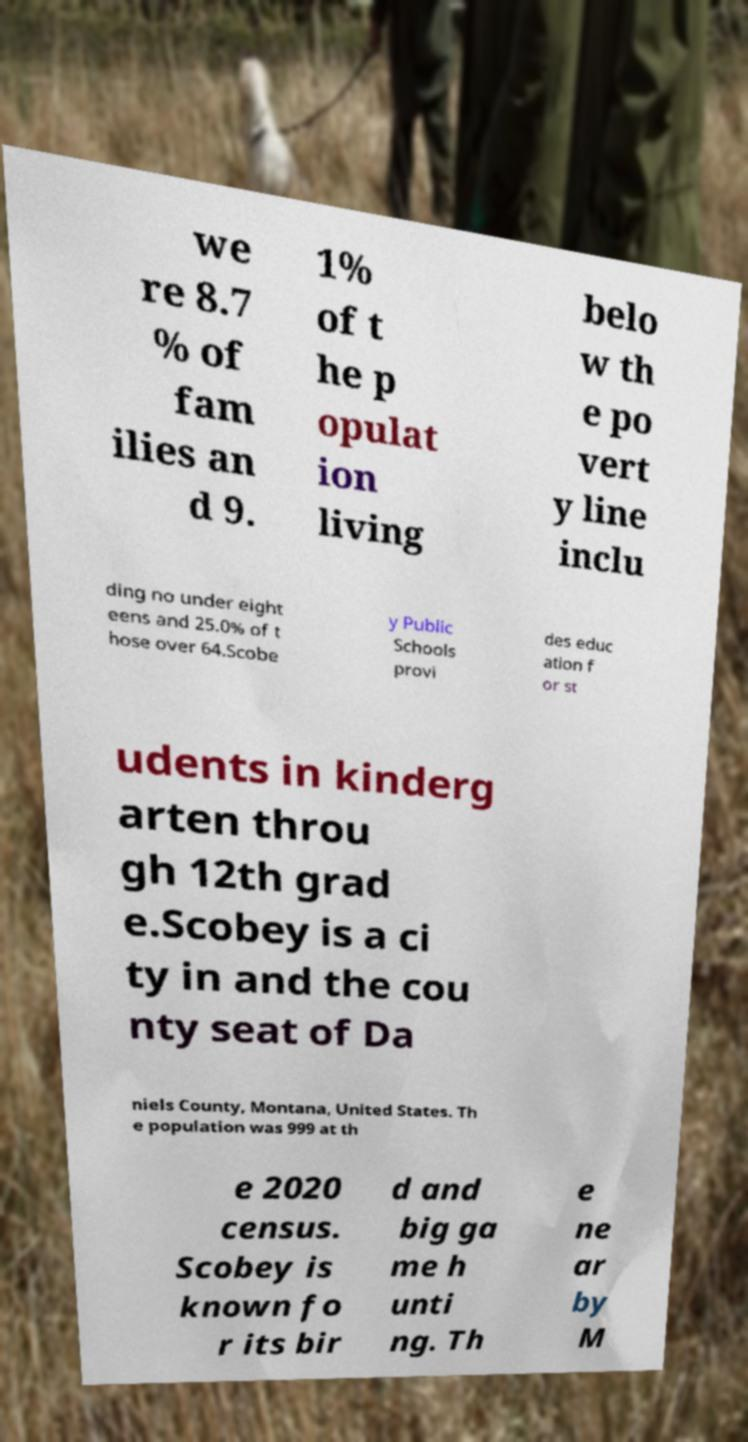Could you extract and type out the text from this image? we re 8.7 % of fam ilies an d 9. 1% of t he p opulat ion living belo w th e po vert y line inclu ding no under eight eens and 25.0% of t hose over 64.Scobe y Public Schools provi des educ ation f or st udents in kinderg arten throu gh 12th grad e.Scobey is a ci ty in and the cou nty seat of Da niels County, Montana, United States. Th e population was 999 at th e 2020 census. Scobey is known fo r its bir d and big ga me h unti ng. Th e ne ar by M 